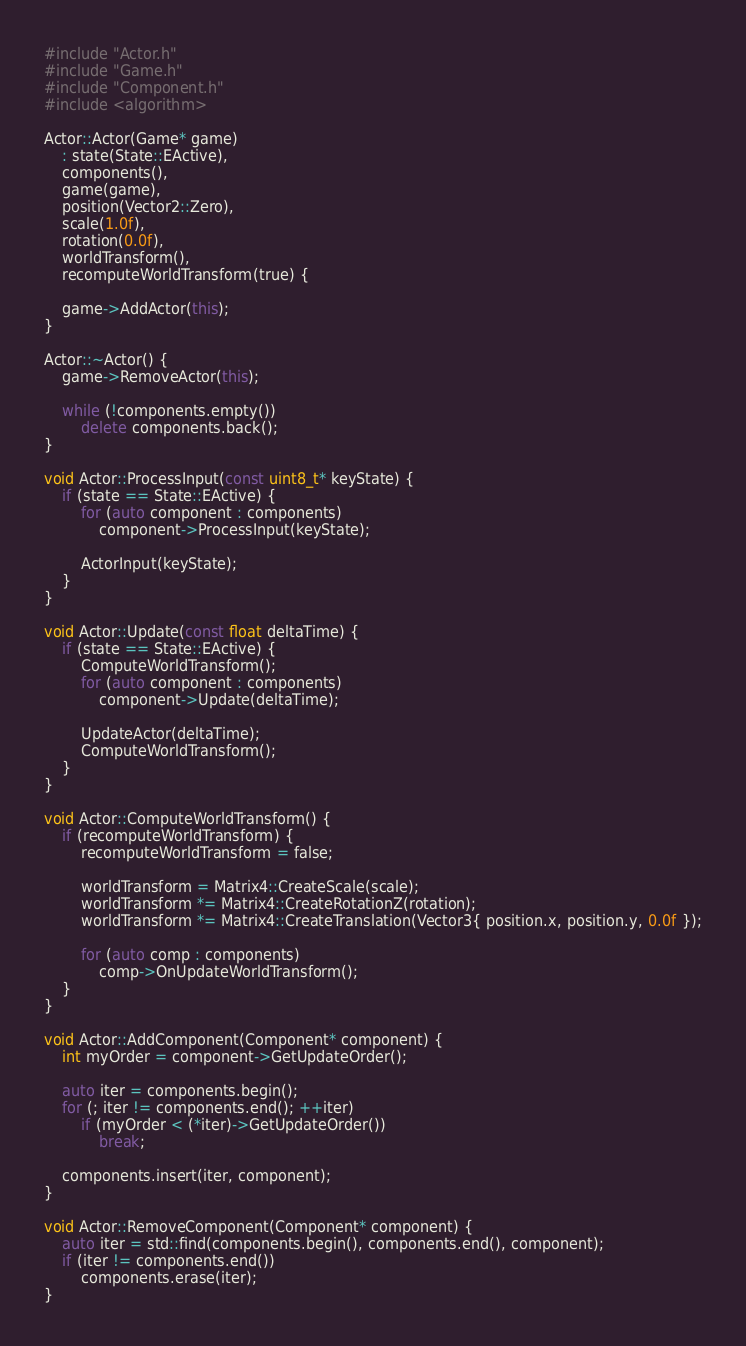<code> <loc_0><loc_0><loc_500><loc_500><_C++_>#include "Actor.h"
#include "Game.h"
#include "Component.h"
#include <algorithm>

Actor::Actor(Game* game)
	: state(State::EActive),
	components(),
	game(game),
	position(Vector2::Zero),
	scale(1.0f),
	rotation(0.0f),
	worldTransform(),
	recomputeWorldTransform(true) {

	game->AddActor(this);
}

Actor::~Actor() {
	game->RemoveActor(this);

	while (!components.empty())
		delete components.back();
}

void Actor::ProcessInput(const uint8_t* keyState) {
	if (state == State::EActive) {
		for (auto component : components)
			component->ProcessInput(keyState);

		ActorInput(keyState);
	}
}

void Actor::Update(const float deltaTime) {
	if (state == State::EActive) {
		ComputeWorldTransform();
		for (auto component : components)
			component->Update(deltaTime);

		UpdateActor(deltaTime);
		ComputeWorldTransform();
	}
}

void Actor::ComputeWorldTransform() {
	if (recomputeWorldTransform) {
		recomputeWorldTransform = false;

		worldTransform = Matrix4::CreateScale(scale);
		worldTransform *= Matrix4::CreateRotationZ(rotation);
		worldTransform *= Matrix4::CreateTranslation(Vector3{ position.x, position.y, 0.0f });

		for (auto comp : components)
			comp->OnUpdateWorldTransform();
	}
}

void Actor::AddComponent(Component* component) {
	int myOrder = component->GetUpdateOrder();

	auto iter = components.begin();
	for (; iter != components.end(); ++iter)
		if (myOrder < (*iter)->GetUpdateOrder())
			break;

	components.insert(iter, component);
}

void Actor::RemoveComponent(Component* component) {
	auto iter = std::find(components.begin(), components.end(), component);
	if (iter != components.end())
		components.erase(iter);
}</code> 